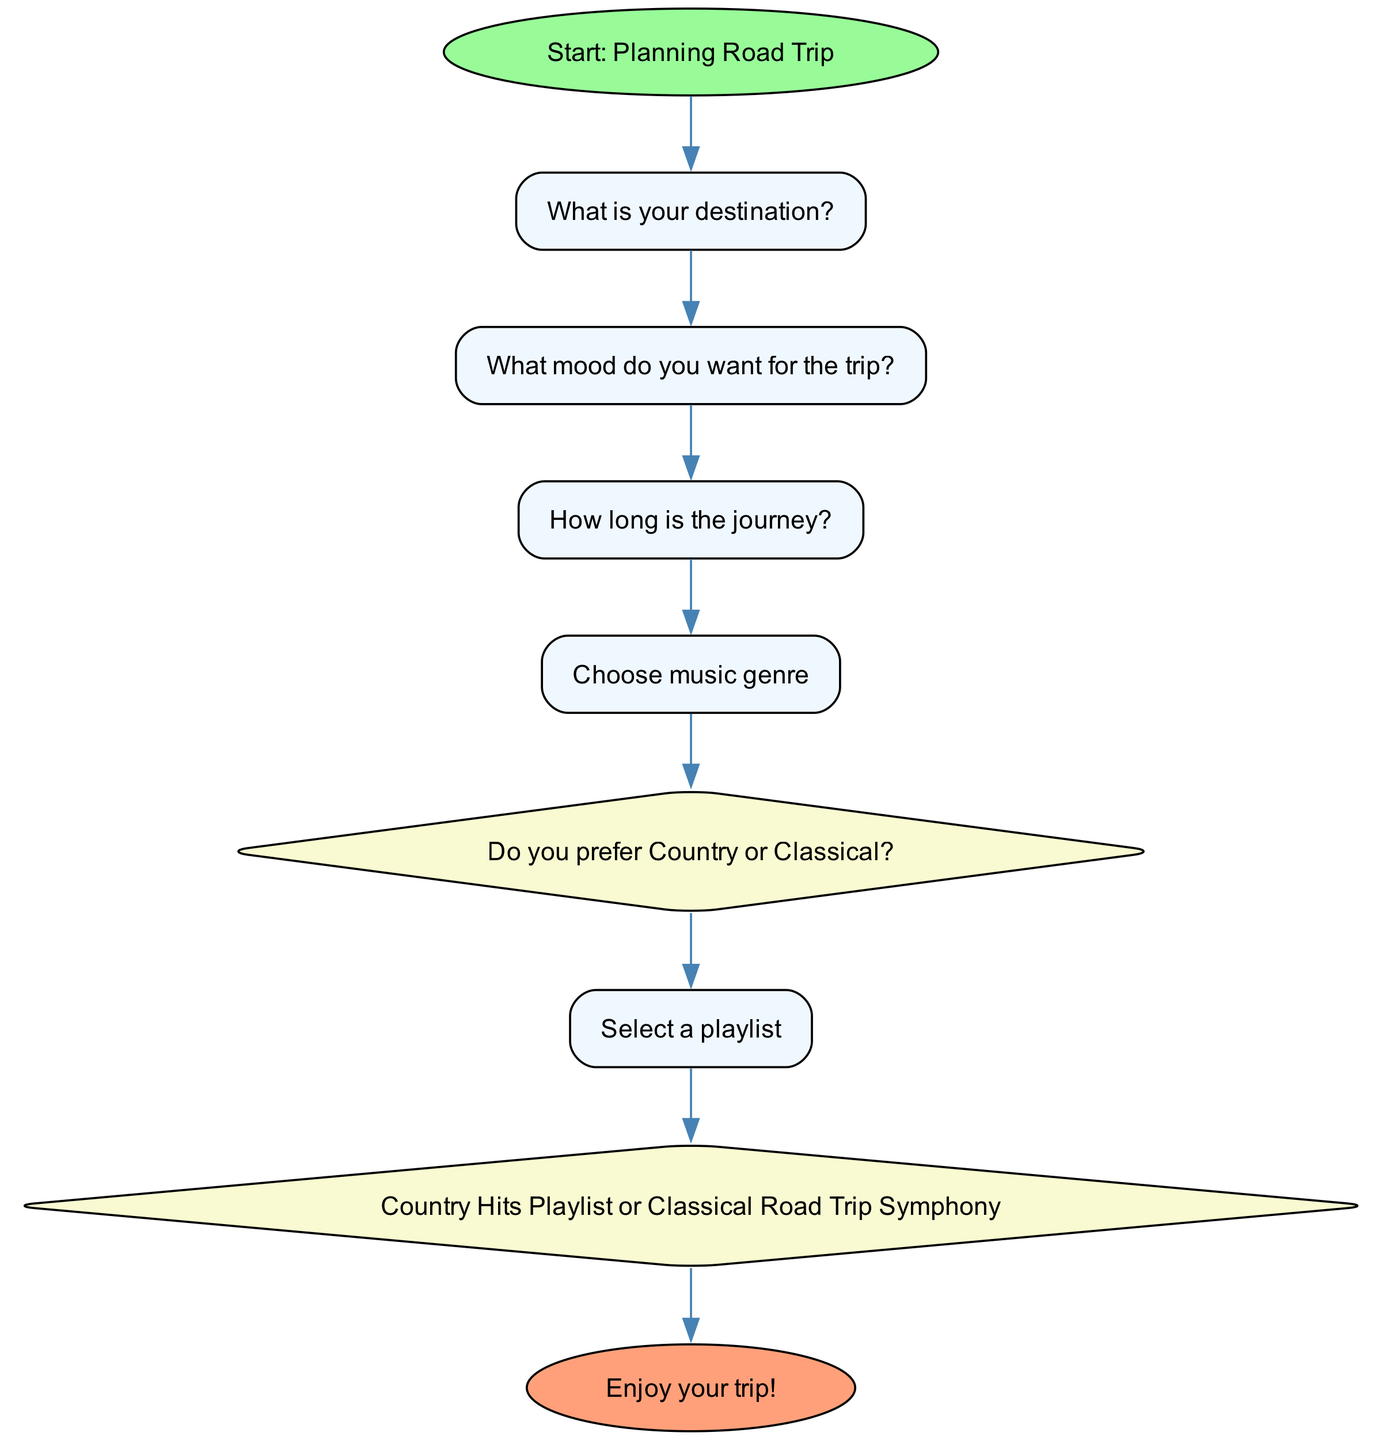What is the starting point of the flowchart? The starting point of the flowchart is labeled "Start: Planning Road Trip", which is the first node in the diagram, indicating where the decision-making process begins.
Answer: Start: Planning Road Trip What node follows "What mood do you want for the trip?" The node that follows "What mood do you want for the trip?" is "How long is the journey?", which connects directly to the previous node, indicating the next question to consider.
Answer: How long is the journey? How many different genres can be selected in the flowchart? The flowchart includes options for selecting music genres, specifically leading to a decision between "Country" and "Classical". Therefore, there are two genres depicted in the diagram.
Answer: 2 What happens after "Select a playlist"? After "Select a playlist", the next step is "Country Hits Playlist or Classical Road Trip Symphony", which indicates that a specific playlist selection occurs next in the flowchart.
Answer: Country Hits Playlist or Classical Road Trip Symphony If the journey length is short, what type of music selection does the diagram provide? The flowchart does not differentiate the type of music based on journey length; it proceeds from one decision to another, leading to genre selection without specifying short or long preferences specifically. However, once genre is chosen, the final options are still available, suggesting that those genres are suitable for any trip length.
Answer: Not specified 